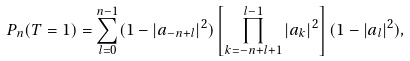Convert formula to latex. <formula><loc_0><loc_0><loc_500><loc_500>P _ { n } ( T = 1 ) = \sum ^ { n - 1 } _ { l = 0 } ( 1 - | a _ { - n + l } | ^ { 2 } ) \left [ \prod ^ { l - 1 } _ { k = - n + l + 1 } | a _ { k } | ^ { 2 } \right ] ( 1 - | a _ { l } | ^ { 2 } ) ,</formula> 